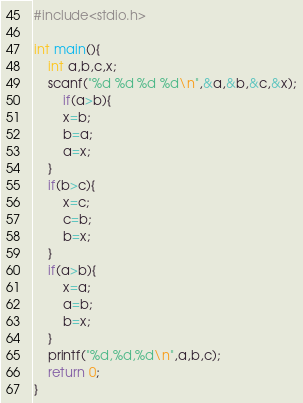Convert code to text. <code><loc_0><loc_0><loc_500><loc_500><_C_>#include<stdio.h>

int main(){
	int a,b,c,x;
	scanf("%d %d %d %d\n",&a,&b,&c,&x);
        if(a>b){
		x=b;
		b=a;
		a=x;
	}
	if(b>c){
		x=c;
		c=b;
		b=x;
	}
	if(a>b){
		x=a;
		a=b;
		b=x;
	}
	printf("%d,%d,%d\n",a,b,c);
	return 0;
}</code> 